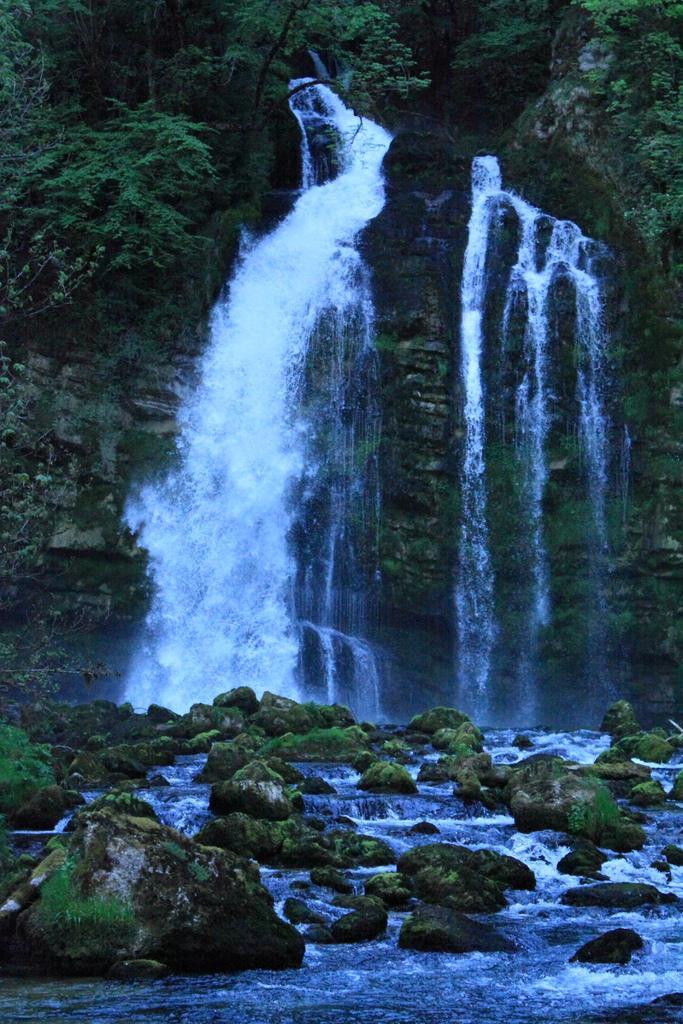Could you give a brief overview of what you see in this image? In the picture we can see water falls from the hills and to the hill we can see some plants and to the down we can see water and some rocks. 